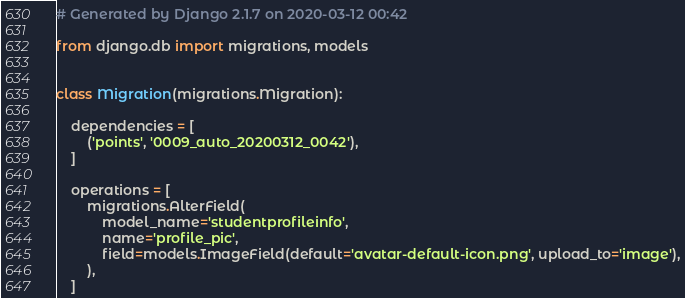<code> <loc_0><loc_0><loc_500><loc_500><_Python_># Generated by Django 2.1.7 on 2020-03-12 00:42

from django.db import migrations, models


class Migration(migrations.Migration):

    dependencies = [
        ('points', '0009_auto_20200312_0042'),
    ]

    operations = [
        migrations.AlterField(
            model_name='studentprofileinfo',
            name='profile_pic',
            field=models.ImageField(default='avatar-default-icon.png', upload_to='image'),
        ),
    ]
</code> 